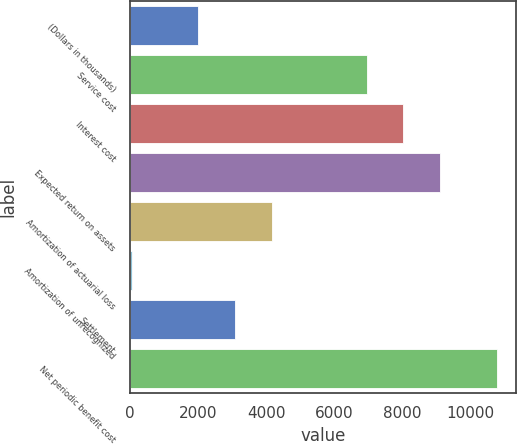Convert chart to OTSL. <chart><loc_0><loc_0><loc_500><loc_500><bar_chart><fcel>(Dollars in thousands)<fcel>Service cost<fcel>Interest cost<fcel>Expected return on assets<fcel>Amortization of actuarial loss<fcel>Amortization of unrecognized<fcel>Settlement<fcel>Net periodic benefit cost<nl><fcel>2010<fcel>6944<fcel>8017.4<fcel>9090.8<fcel>4156.8<fcel>49<fcel>3083.4<fcel>10783<nl></chart> 